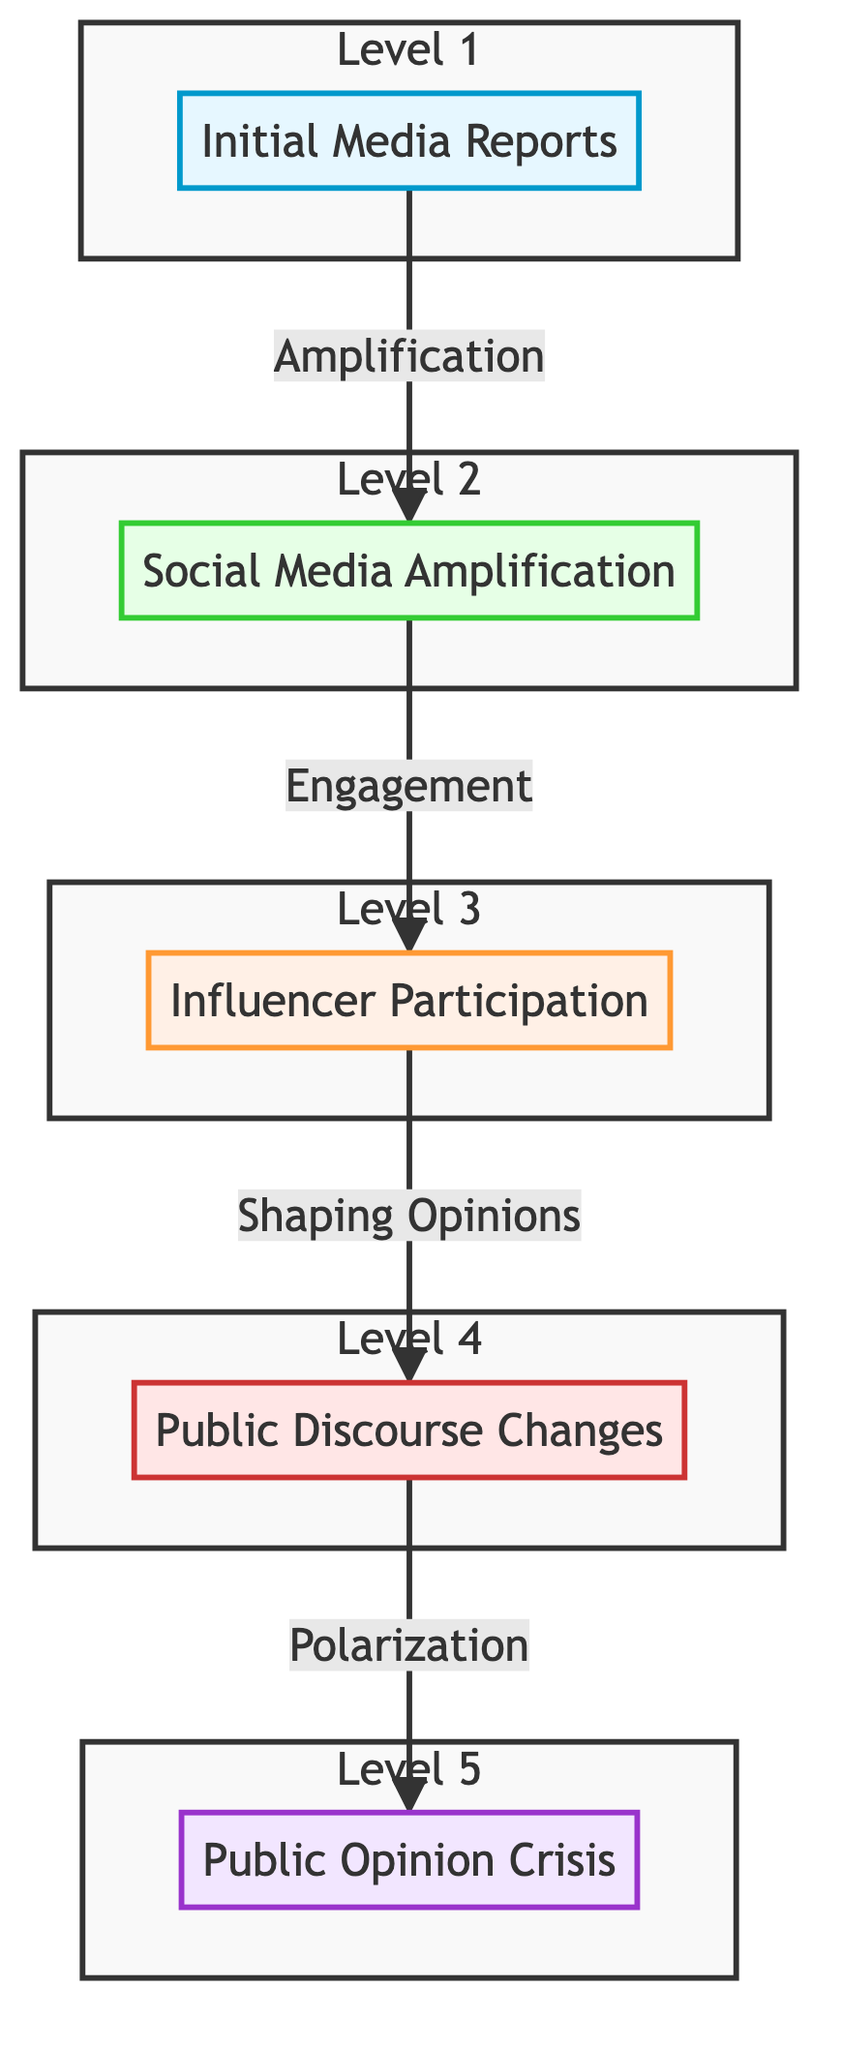What is the top stage of the flowchart? The flowchart progresses upward from "Initial Media Reports" to "Public Opinion Crisis" as the final stage. Therefore, the top stage is "Public Opinion Crisis."
Answer: Public Opinion Crisis How many stages are represented in the flowchart? By counting each distinct stage from "Initial Media Reports" to "Public Opinion Crisis," the flowchart has five stages.
Answer: Five Which stage directly precedes "Public Discourse Changes"? The flowchart shows a direct connection from "Influencer and Public Figures' Participation" to "Public Discourse Changes," indicating this stage immediately precedes the discourse changes.
Answer: Influencer and Public Figures' Participation What type of engagement is described between "Social Media Amplification" and "Influencer and Public Figures' Participation"? The flowchart indicates an "Engagement" relationship between these two stages, suggesting the progression of how social media responses facilitate influencer involvement.
Answer: Engagement What is the relationship connecting "Public Discourse Changes" to "Public Opinion Crisis"? The flowchart denotes a causal relationship labeled "Polarization," which illustrates how changes in public discourse lead to the culmination in a public opinion crisis.
Answer: Polarization Which stage is enhanced by trending hashtags according to the flowchart? The flowchart states that "Social Media Amplification" is the stage enhanced by the occurrence of trending hashtags and viral posts, as it illustrates how media coverage is further spread.
Answer: Social Media Amplification What emotional state is reflected in "Public Discourse Changes"? The description for "Public Discourse Changes" mentions "heightened emotions," reflecting the emotional intensity present in public discussions during this stage.
Answer: Heightened emotions Which stage features participation from influencers? In the flowchart, the stage that involves participation from influencers and public figures is specifically labeled "Influencer and Public Figures' Participation."
Answer: Influencer and Public Figures' Participation 